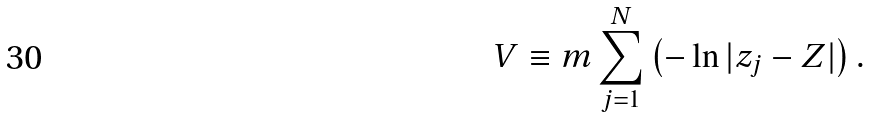Convert formula to latex. <formula><loc_0><loc_0><loc_500><loc_500>V \equiv m \sum _ { j = 1 } ^ { N } \left ( - \ln { | z _ { j } - Z | } \right ) .</formula> 